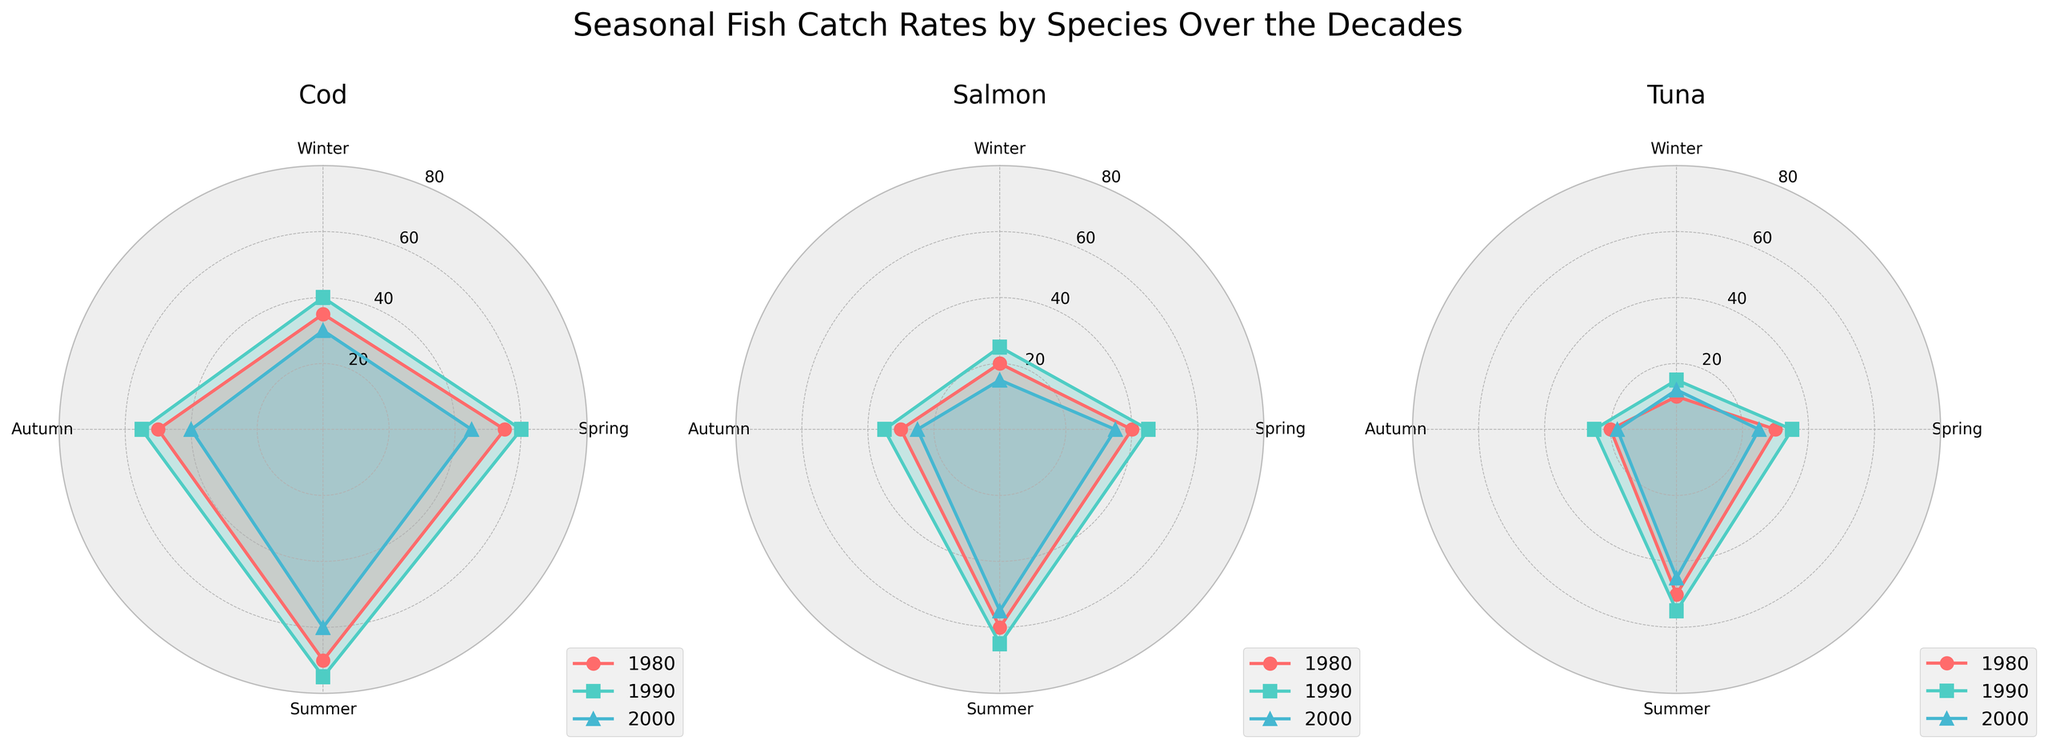Which season consistently has the highest catch rates for Cod? To determine this, we need to compare the catch rates of Cod over Winter, Spring, Summer, and Autumn in each of the three decades. From the figure, it's clear that Summer consistently has the highest catch rates across all decades.
Answer: Summer How did the catch rates for Tuna in Winter compare across the decades? Looking at the Tuna subplot, we can see the lines corresponding to Winter's catch rates. The catch rate in 1980 was 10, in 1990 it increased to 15, and in 2000 it slightly decreased to 12.
Answer: Increased from 1980 to 1990, then decreased in 2000 What is the trend in Salmon catch rates in Autumn from 1980 to 2000? Observing the Salmon subplot, the catch rate in Autumn was 30 in 1980, 35 in 1990, and it decreased to 25 in 2000. This shows a general decreasing trend.
Answer: Decreasing Which species had the highest catch rate in Spring in the year 1990? We need to compare the catch rates in Spring for Cod, Salmon, and Tuna in 1990. The Cod had 60, Salmon had 45, and Tuna had 35. Cod had the highest catch rate.
Answer: Cod What is the average catch rate of Cod across all seasons in the year 1980? The seasonal catch rates for Cod in 1980 are 35 (Winter), 55 (Spring), 70 (Summer), and 50 (Autumn). To find the average, add them up and divide by 4: (35 + 55 + 70 + 50) / 4 = 210 / 4 = 52.5.
Answer: 52.5 Is there a season where all three species have decreasing catch rates from the 1990s to the 2000s? We need to compare the catch rates for each species in each season going from 1990 to 2000. Winter: Cod (40 to 30), Salmon (25 to 15), Tuna (15 to 12)—all decreased. Spring, Summer, and Autumn do not show a decreasing trend across all species.
Answer: Winter How do the catch rates of Salmon in Summer vary between the years 1980, 1990, and 2000? Check the Salmon subplot for Summer. The catch rates for 1980, 1990, and 2000 are 60, 65, and 55, respectively. The rates increased from 1980 to 1990, then decreased in 2000.
Answer: Increased then decreased Which species shows the most significant drop in catch rates during Summer from 1990 to 2000? Looking at the Summer data in each subplot for the years 1990 and 2000, Cod decreased from 75 to 60 (15 units), Salmon decreased from 65 to 55 (10 units), and Tuna decreased from 55 to 45 (10 units). Cod shows the most significant drop.
Answer: Cod 